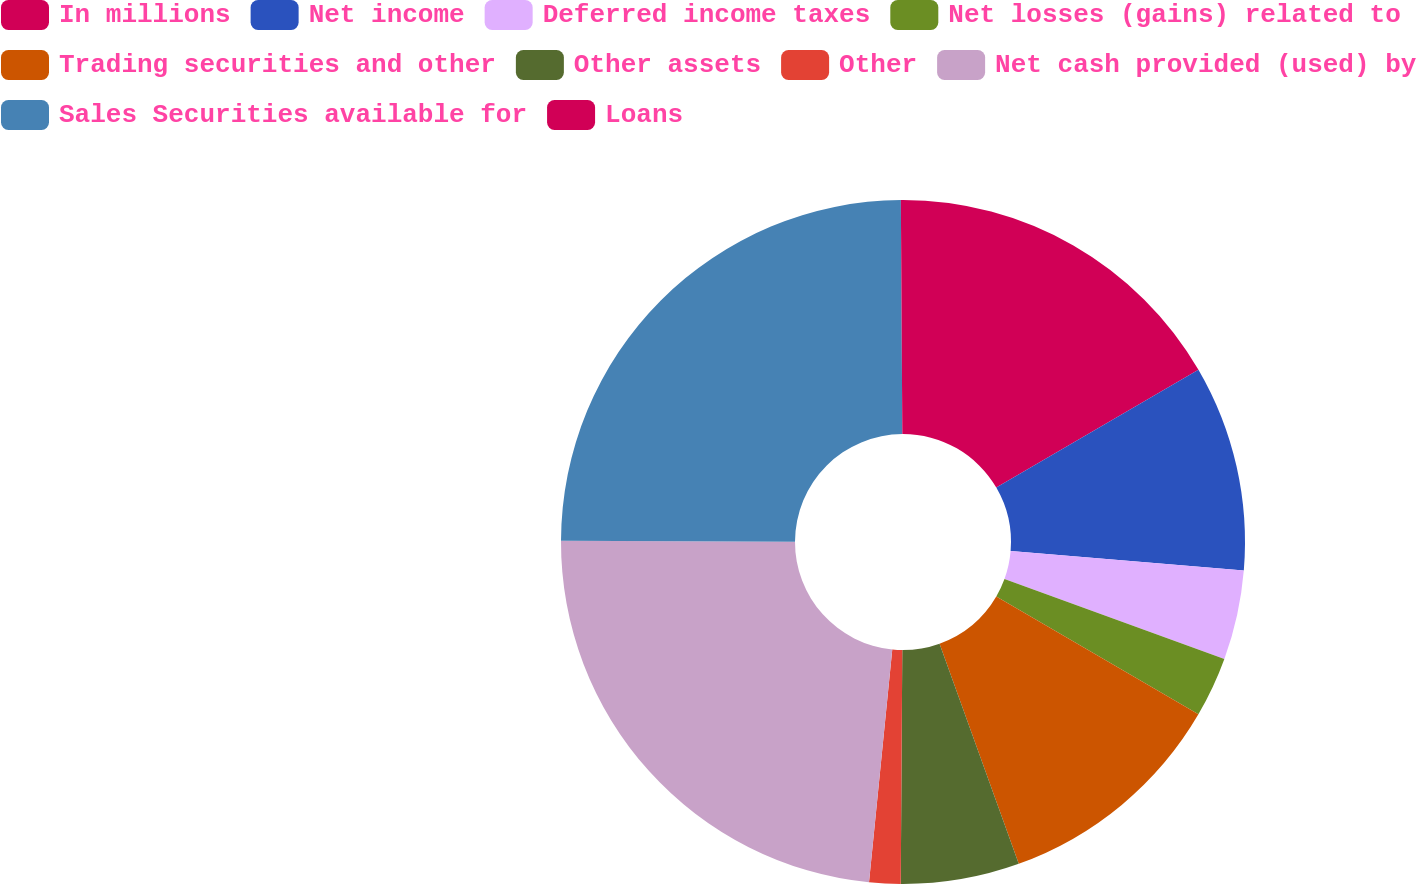<chart> <loc_0><loc_0><loc_500><loc_500><pie_chart><fcel>In millions<fcel>Net income<fcel>Deferred income taxes<fcel>Net losses (gains) related to<fcel>Trading securities and other<fcel>Other assets<fcel>Other<fcel>Net cash provided (used) by<fcel>Sales Securities available for<fcel>Loans<nl><fcel>16.6%<fcel>9.73%<fcel>4.23%<fcel>2.85%<fcel>11.1%<fcel>5.6%<fcel>1.48%<fcel>23.47%<fcel>24.85%<fcel>0.1%<nl></chart> 